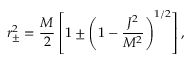Convert formula to latex. <formula><loc_0><loc_0><loc_500><loc_500>r _ { \pm } ^ { 2 } = { \frac { M } { 2 } } \left [ 1 \pm \left ( 1 - { \frac { J ^ { 2 } } { M ^ { 2 } } } \right ) ^ { 1 / 2 } \right ] ,</formula> 